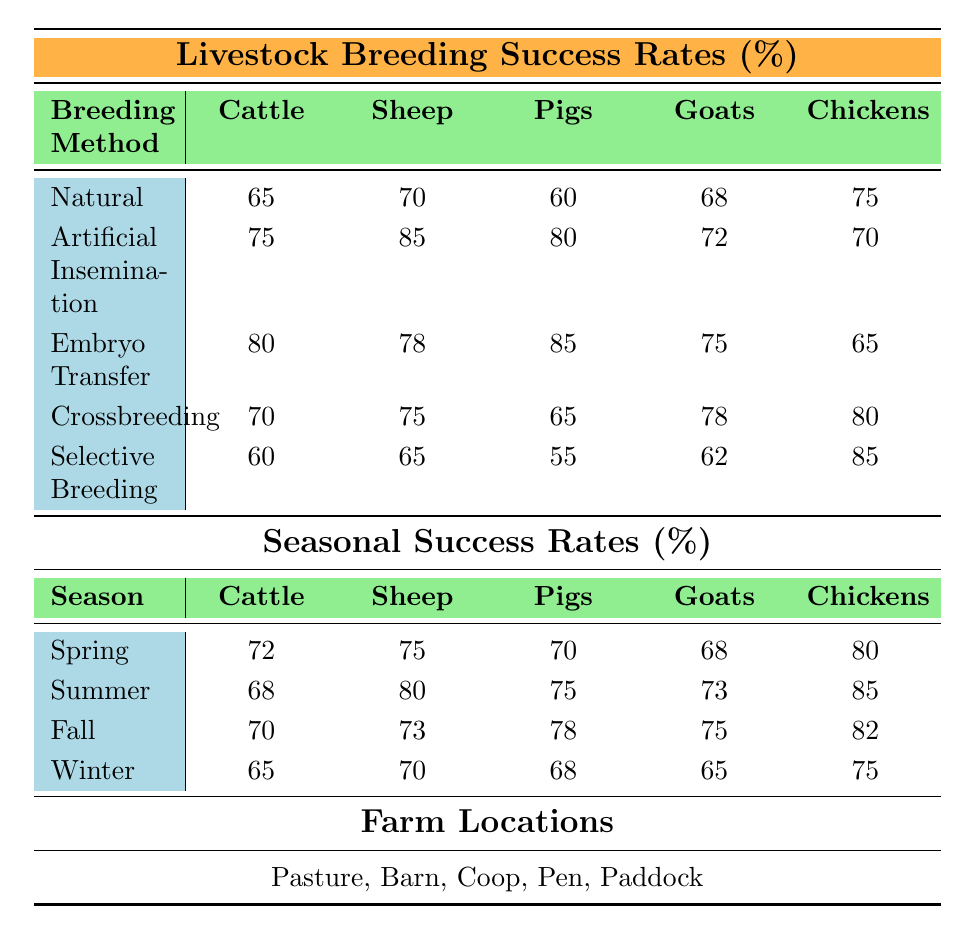What is the success rate for Artificial Insemination in Sheep? The table shows that the success rate for Artificial Insemination in Sheep is 85%.
Answer: 85% Which breeding method has the highest success rate for Pigs? Looking at the breeding method success rates, Embryo Transfer has the highest success rate for Pigs at 85%.
Answer: 85% What is the average success rate for Natural breeding across all animals? The success rates for Natural breeding in each animal are 65 (Cattle), 70 (Sheep), 60 (Pigs), 68 (Goats), and 75 (Chickens). The average is calculated as (65 + 70 + 60 + 68 + 75) / 5 = 67.6.
Answer: 67.6 What is the lowest seasonal success rate for Goats? By examining the seasonal success rates for Goats, we see that Winter has the lowest success rate at 65%.
Answer: 65% Which animal had the highest success rate in the Summer season? Looking at the Summer seasonal success rates, Chickens have the highest rate at 85%.
Answer: 85% Is the success rate for Selective Breeding in Cattle higher than that for Crossbreeding? For Cattle, the success rates are 60 for Selective Breeding and 70 for Crossbreeding. Since 60 < 70, Selective Breeding is not higher.
Answer: No What is the difference in success rates between Artificial Insemination for Cattle and Sheep? The success rate for Artificial Insemination for Cattle is 75%, and for Sheep, it is 85%. The difference is calculated as 85 - 75 = 10.
Answer: 10 In which season do Chickens have the highest breeding success rate? Looking at the seasonal success rates for Chickens, we find that the highest success rate is in Summer at 85%.
Answer: Summer What is the overall trend for breeding success rates across the seasons for Pigs? By analyzing the seasonal success rates for Pigs: Spring (70), Summer (75), Fall (78), Winter (68), we see that the rates generally rise and then fall in Winter. So, the trend is increasing then decreasing.
Answer: Increasing then decreasing Which breeding method has the lowest overall success rate across all animals? By looking at the success rates, Selective Breeding has the lowest overall success rate of 60% for Cattle.
Answer: 60% 